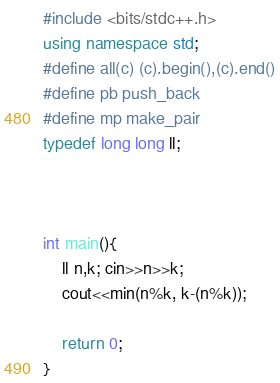Convert code to text. <code><loc_0><loc_0><loc_500><loc_500><_C++_>#include <bits/stdc++.h>
using namespace std;
#define all(c) (c).begin(),(c).end()
#define pb push_back 
#define mp make_pair
typedef long long ll;



int main(){
	ll n,k; cin>>n>>k;
	cout<<min(n%k, k-(n%k));
			
	return 0;
}
</code> 